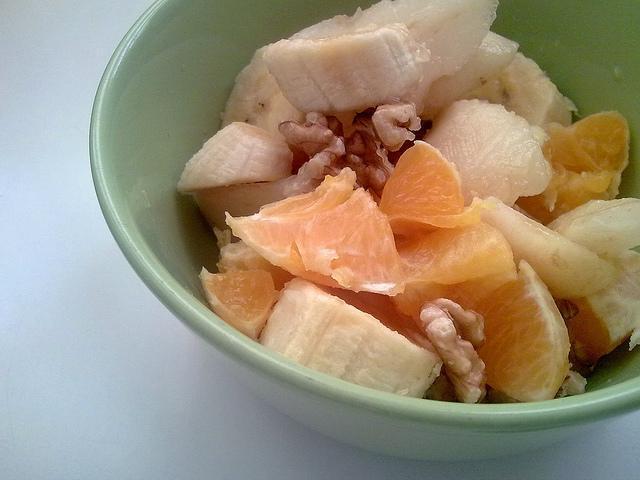How many oranges are there?
Give a very brief answer. 7. How many bananas can you see?
Give a very brief answer. 6. 